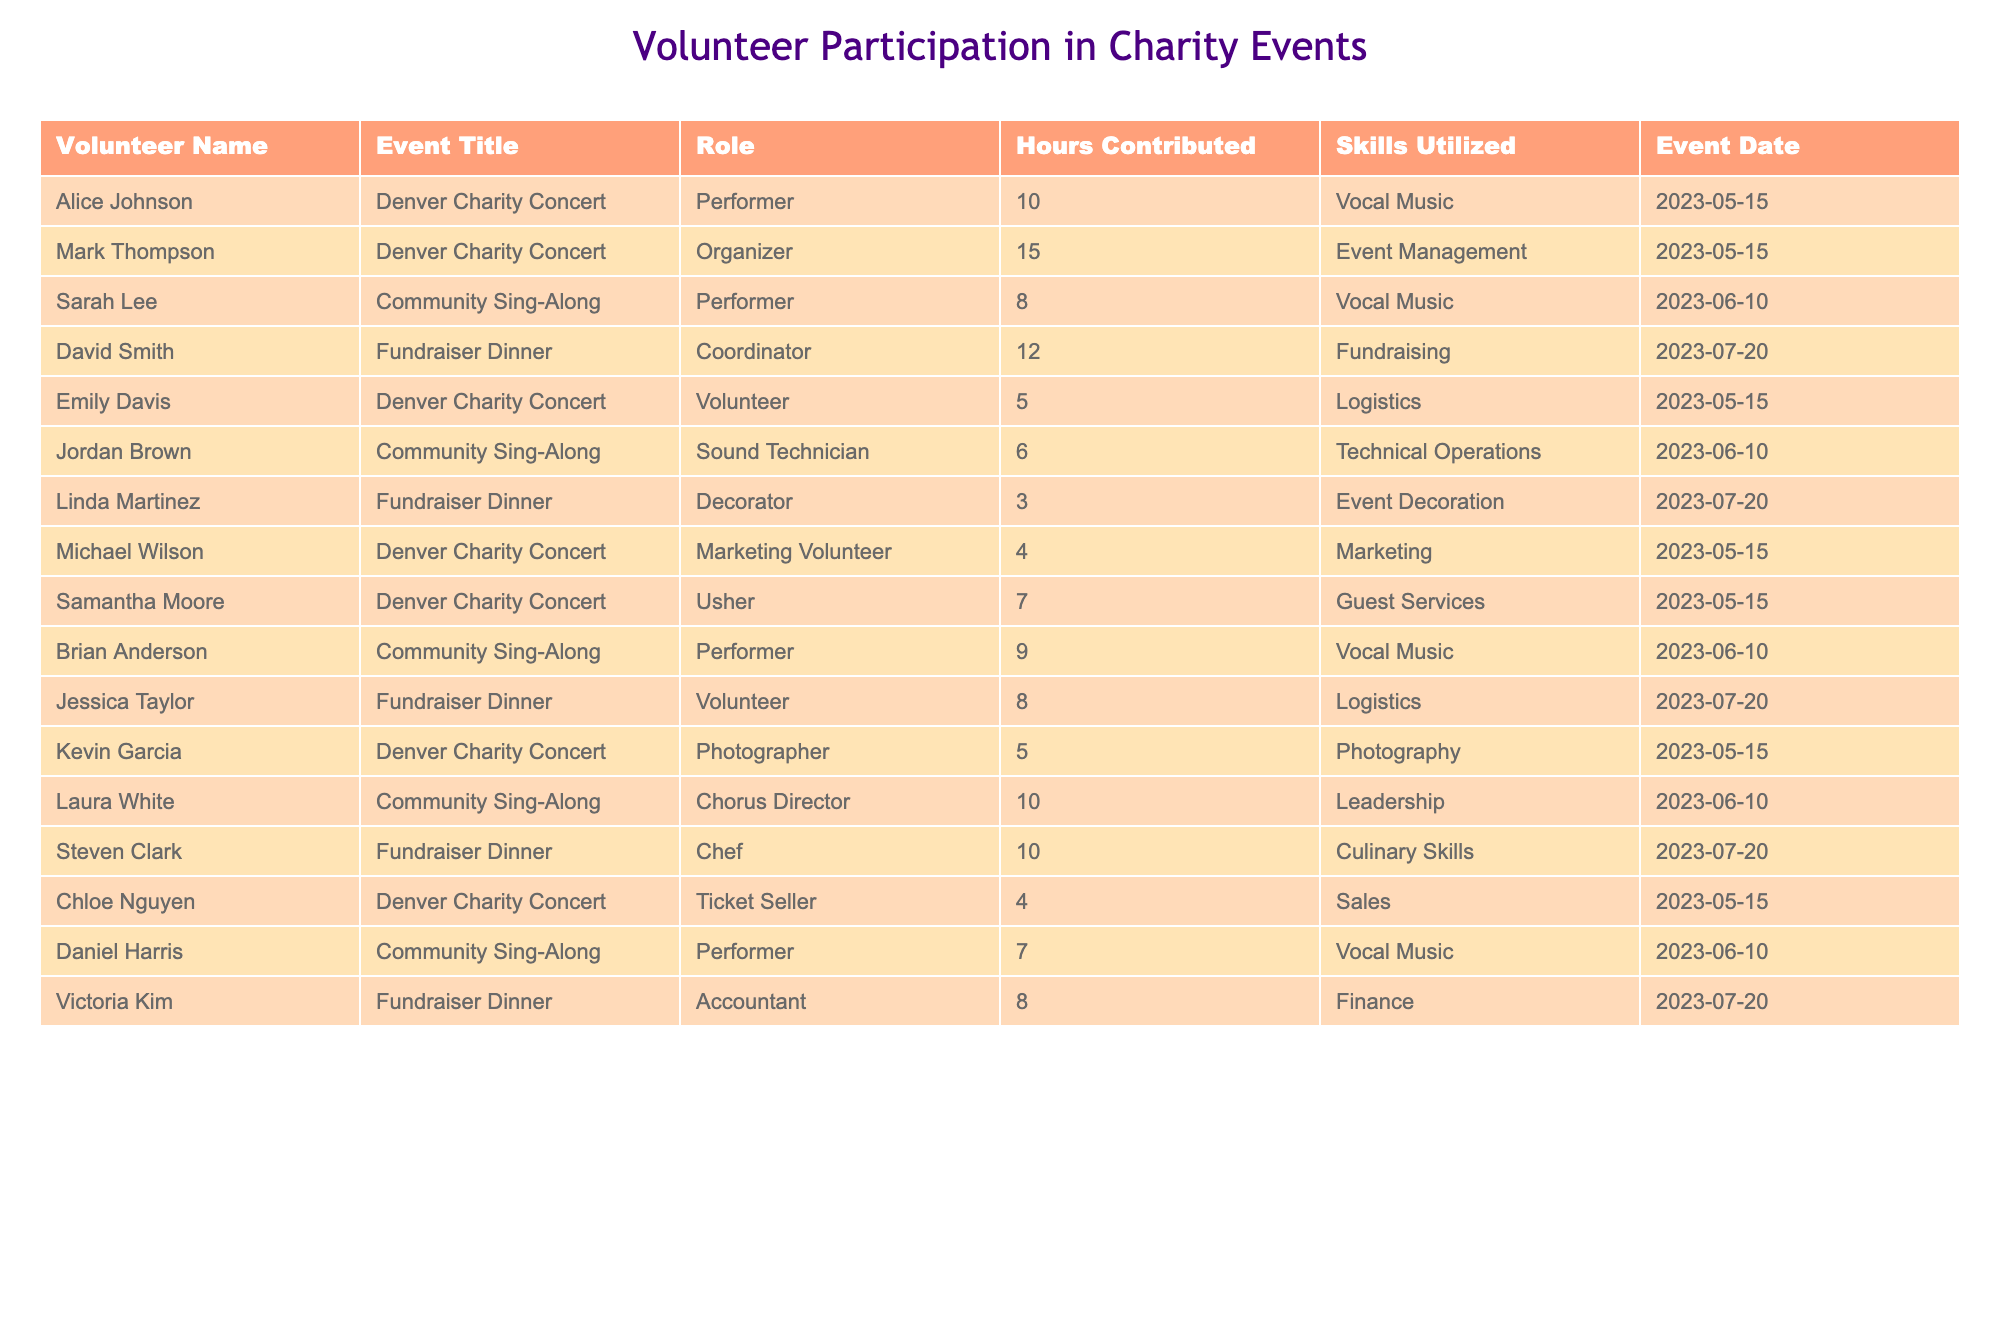What is the total number of hours contributed by all volunteers for the Denver Charity Concert? To find the total hours contributed for the Denver Charity Concert, we sum the hours from all volunteers listed for that event: 10 (Alice) + 15 (Mark) + 5 (Emily) + 4 (Michael) + 7 (Samantha) + 5 (Kevin) + 4 (Chloe) = 50.
Answer: 50 Who served as the Coordinator for the Fundraiser Dinner event? The table lists David Smith as the Coordinator for the Fundraiser Dinner event.
Answer: David Smith How many hours did performers contribute at the Community Sing-Along? We identify the performers from the Community Sing-Along: Sarah (8 hours), Brian (9 hours), and Daniel (7 hours). The total for performers is 8 + 9 + 7 = 24 hours.
Answer: 24 Which volunteer contributed the least amount of hours in the Fundraiser Dinner? The event shows Linda Martinez (Decorator) contributed 3 hours, which is the least among the listed roles.
Answer: Linda Martinez True or False: Emily Davis contributed more hours than Kevin Garcia for the Denver Charity Concert. Emily contributed 5 hours while Kevin contributed 5 hours, meaning they contributed the same, making the statement false.
Answer: False What is the average number of hours contributed by volunteers in the Fundraiser Dinner? The hours contributed for the Fundraiser Dinner are 12 (David) + 3 (Linda) + 10 (Steven) + 8 (Victoria) = 33 hours. There are 4 volunteers, so the average is 33/4 = 8.25 hours.
Answer: 8.25 How many different roles did volunteers take on during the Denver Charity Concert? The roles listed for the Denver Charity Concert are Performer, Organizer, Volunteer, Marketing Volunteer, Usher, Photographer, and Ticket Seller, giving us 7 different roles in total.
Answer: 7 What percentage of total hours for the Community Sing-Along were contributed by the Chorus Director? The total hours for the Community Sing-Along are 8 (Sarah) + 9 (Brian) + 7 (Daniel) + 6 (Jordan) + 10 (Laura) = 40 hours. Laura, the Chorus Director, contributed 10 hours. The percentage is (10/40) * 100 = 25%.
Answer: 25% Which event had the highest total contribution of hours? We sum the hours for each event: Denver Charity Concert (50 hours), Community Sing-Along (40 hours), Fundraiser Dinner (33 hours). The highest is for the Denver Charity Concert with 50 hours.
Answer: Denver Charity Concert What role had the most contributors in the Charity events combined? Counting the roles across all events, 'Performer' appears 5 times (Alice, Sarah, Brian, Daniel, Jordan), 'Volunteer' appears 3 times (Emily, Jessica), and other roles less often; hence 'Performer' is the most common role.
Answer: Performer 